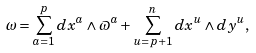<formula> <loc_0><loc_0><loc_500><loc_500>\omega = \sum _ { a = 1 } ^ { p } d x ^ { a } \wedge \varpi ^ { a } + \sum _ { u = p + 1 } ^ { n } d x ^ { u } \wedge d y ^ { u } ,</formula> 